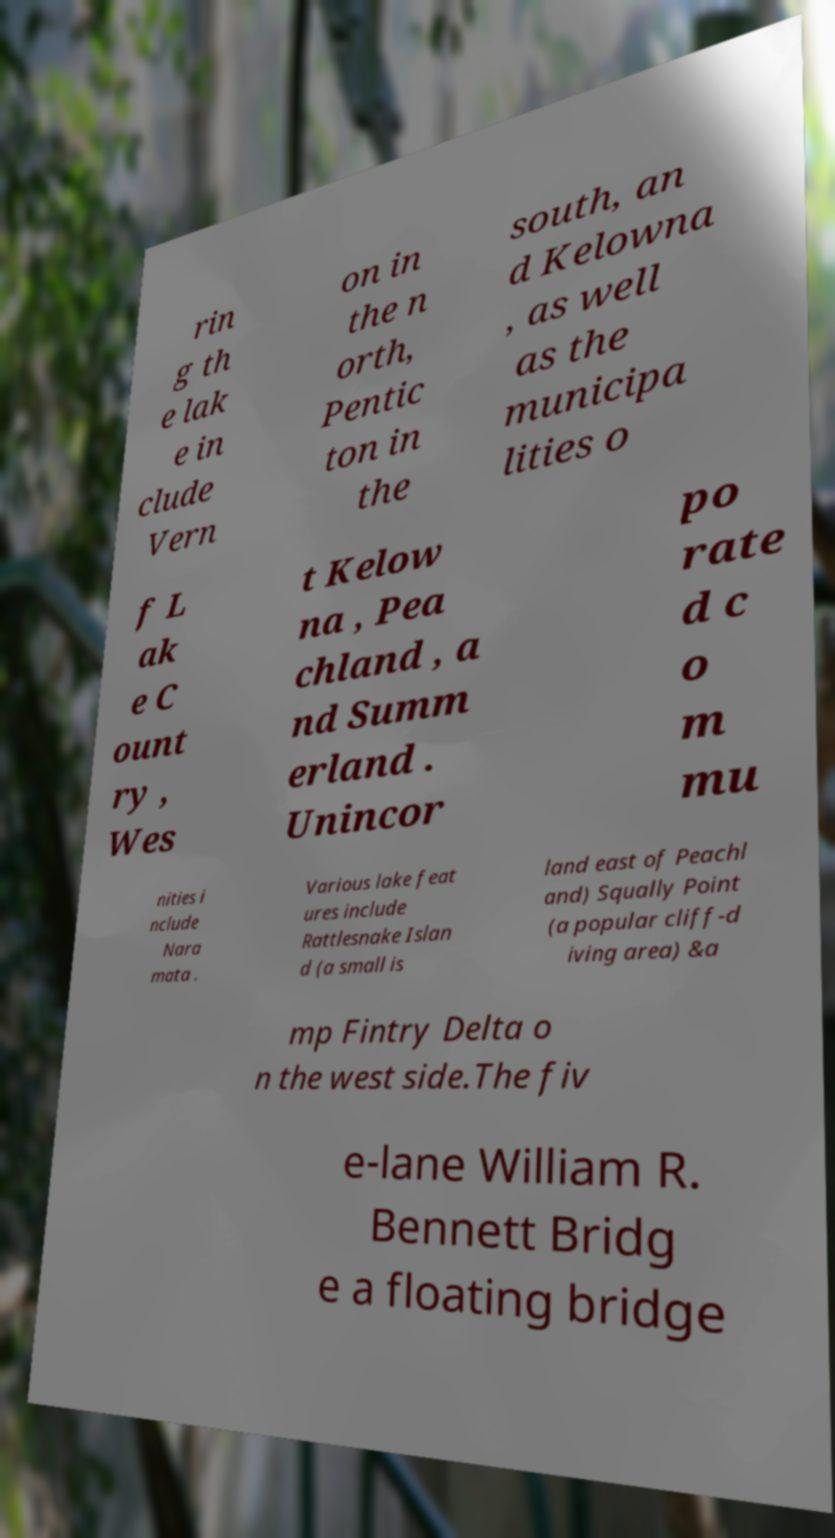Can you accurately transcribe the text from the provided image for me? rin g th e lak e in clude Vern on in the n orth, Pentic ton in the south, an d Kelowna , as well as the municipa lities o f L ak e C ount ry , Wes t Kelow na , Pea chland , a nd Summ erland . Unincor po rate d c o m mu nities i nclude Nara mata . Various lake feat ures include Rattlesnake Islan d (a small is land east of Peachl and) Squally Point (a popular cliff-d iving area) &a mp Fintry Delta o n the west side.The fiv e-lane William R. Bennett Bridg e a floating bridge 